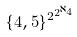Convert formula to latex. <formula><loc_0><loc_0><loc_500><loc_500>\{ 4 , 5 \} ^ { 2 ^ { 2 ^ { \aleph _ { 4 } } } }</formula> 